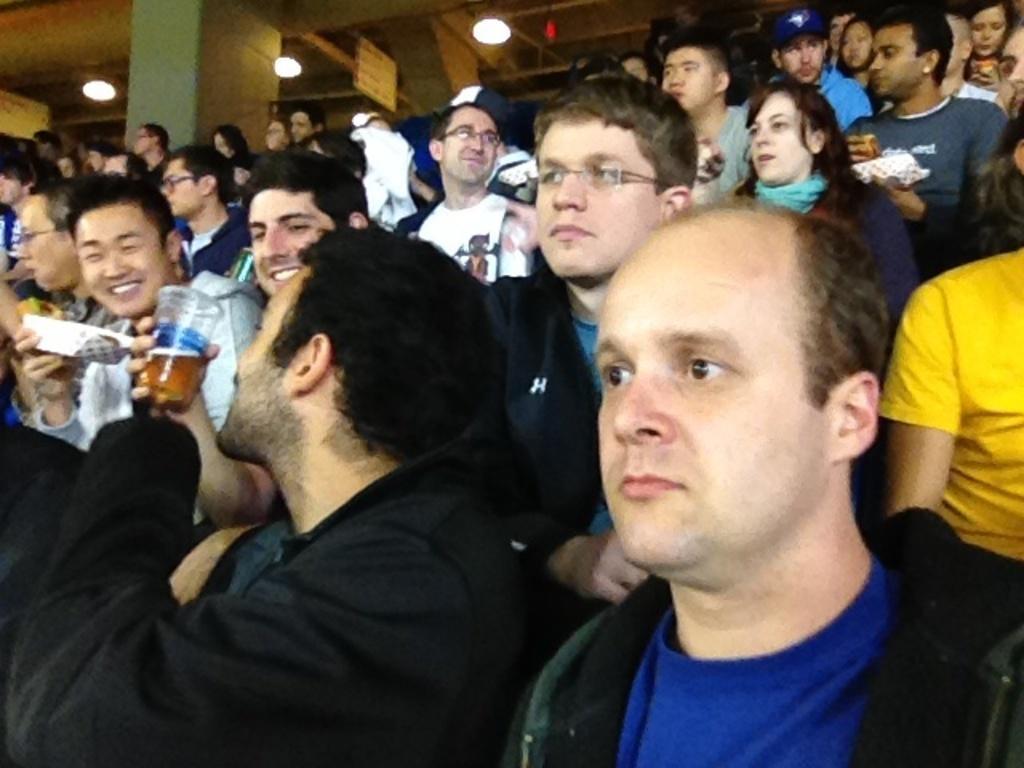In one or two sentences, can you explain what this image depicts? There are many people sitting in the chairs in this picture. One guy is holding a glass in his hands. There are men and women in this group. In the background there is a pillar and some lights. 